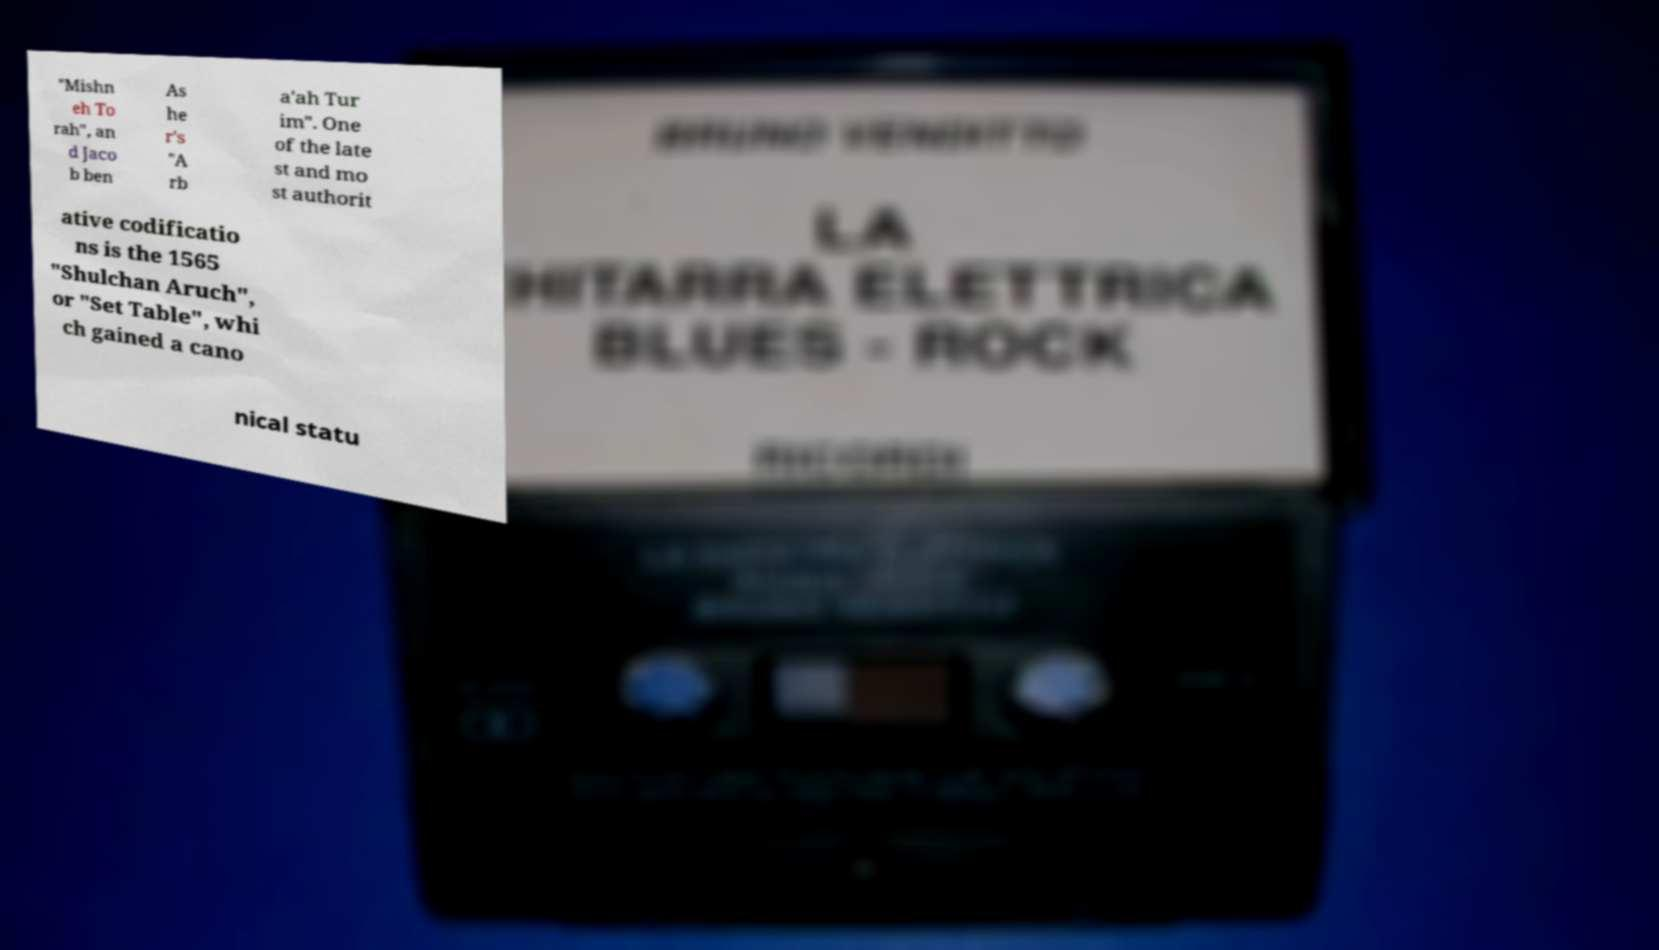Can you accurately transcribe the text from the provided image for me? "Mishn eh To rah", an d Jaco b ben As he r's "A rb a'ah Tur im". One of the late st and mo st authorit ative codificatio ns is the 1565 "Shulchan Aruch", or "Set Table", whi ch gained a cano nical statu 